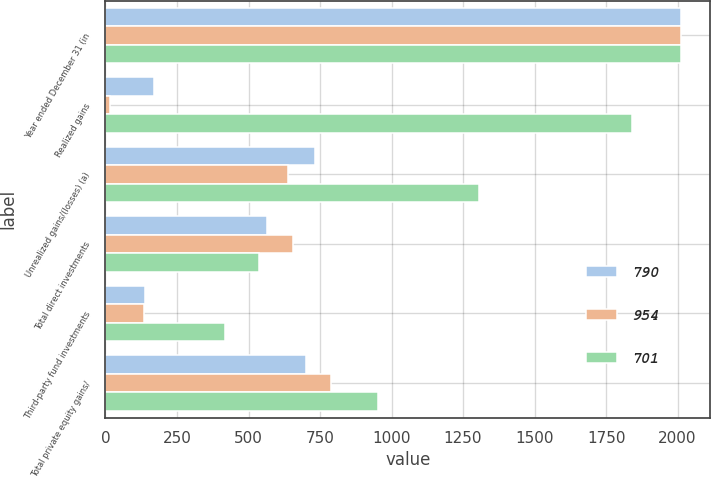<chart> <loc_0><loc_0><loc_500><loc_500><stacked_bar_chart><ecel><fcel>Year ended December 31 (in<fcel>Realized gains<fcel>Unrealized gains/(losses) (a)<fcel>Total direct investments<fcel>Third-party fund investments<fcel>Total private equity gains/<nl><fcel>790<fcel>2013<fcel>170<fcel>734<fcel>564<fcel>137<fcel>701<nl><fcel>954<fcel>2012<fcel>17<fcel>639<fcel>656<fcel>134<fcel>790<nl><fcel>701<fcel>2011<fcel>1842<fcel>1305<fcel>537<fcel>417<fcel>954<nl></chart> 